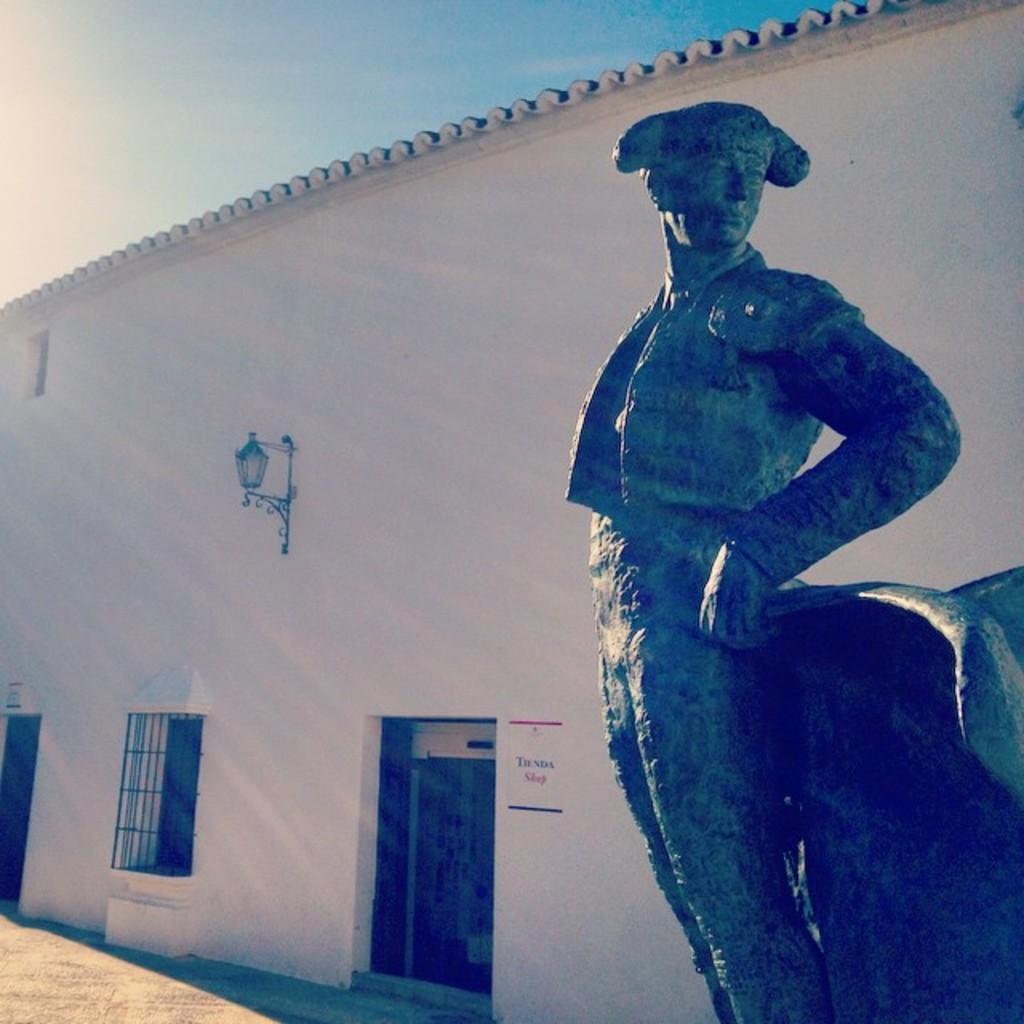Can you describe this image briefly? In this image in the foreground there is one statue, and in the background there is a house, windows, door and on the wall there is some board and some light. At the bottom there is walkway, and at the top of the image there is sky. 